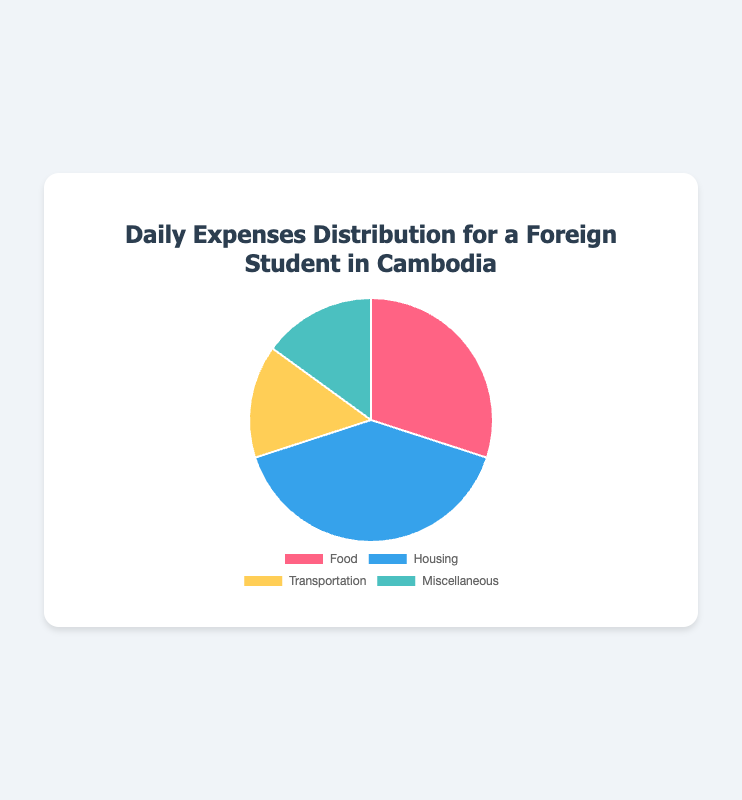What's the largest expense category? By observing the pie chart, the size of the 'Housing' segment is the largest in comparison to other segments such as 'Food', 'Transportation', and 'Miscellaneous'. This indicates that 'Housing' takes up the most significant portion of daily expenses.
Answer: Housing Which two categories have the same percentage of daily expenses? The pie chart shows two segments of equal size which correspond to 'Transportation' and 'Miscellaneous'. Each of these segments represents 15% of the daily expenses.
Answer: Transportation and Miscellaneous What is the combined percentage of 'Food' and 'Transportation' expenses? By summing the percentages for 'Food' and 'Transportation' we get: 30% (for Food) + 15% (for Transportation) = 45%.
Answer: 45% Which category has the least percentage of daily expenses, and what percent is it? The pie chart indicates that both 'Transportation' and 'Miscellaneous' have the least percentage of daily expenses, each representing 15%.
Answer: Transportation and Miscellaneous, 15% How much percentage more does 'Housing' account for compared to 'Miscellaneous'? The percentage for 'Housing' is 40%, and for 'Miscellaneous', it is 15%. The difference is 40% - 15% = 25%.
Answer: 25% Which color represents 'Food' in the pie chart? Observing the colors associated with each segment, 'Food' is represented by the color red.
Answer: Red If we consider 'Housing' and 'Food' together, how much more is their combined percentage compared to 'Transportation' and 'Miscellaneous' together? The combined percentage for 'Housing' (40%) and 'Food' (30%) is 40% + 30% = 70%. The combined percentage for 'Transportation' (15%) and 'Miscellaneous' (15%) is 15% + 15% = 30%. The difference is 70% - 30% = 40%.
Answer: 40% Which category is represented by the blue segment in the pie chart? By referring to the colors of the segments in the pie chart, 'Housing' is represented by the blue segment.
Answer: Housing What is the average percentage of the 'Transportation' and 'Miscellaneous' expenses? The sum of 'Transportation' (15%) and 'Miscellaneous' (15%) is combined to be 30%. The average is 30% / 2 = 15%.
Answer: 15% What's the percentage difference between 'Food' and 'Transportation'? The percentage for 'Food' is 30%, and for 'Transportation', it is 15%. The difference is 30% - 15% = 15%.
Answer: 15% 